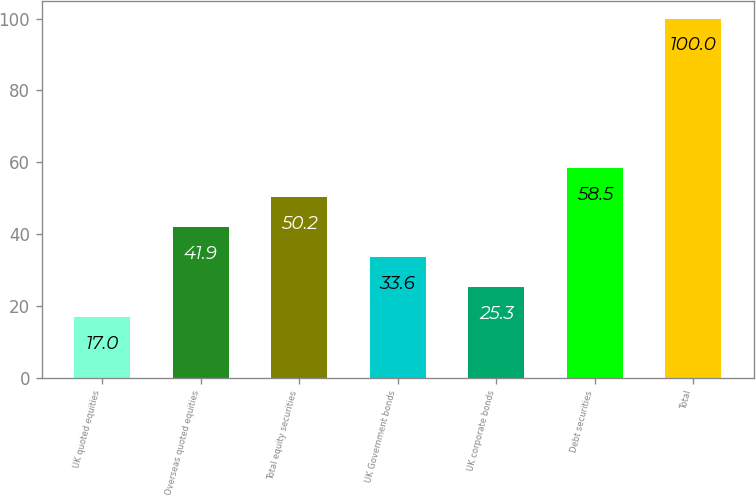<chart> <loc_0><loc_0><loc_500><loc_500><bar_chart><fcel>UK quoted equities<fcel>Overseas quoted equities<fcel>Total equity securities<fcel>UK Government bonds<fcel>UK corporate bonds<fcel>Debt securities<fcel>Total<nl><fcel>17<fcel>41.9<fcel>50.2<fcel>33.6<fcel>25.3<fcel>58.5<fcel>100<nl></chart> 